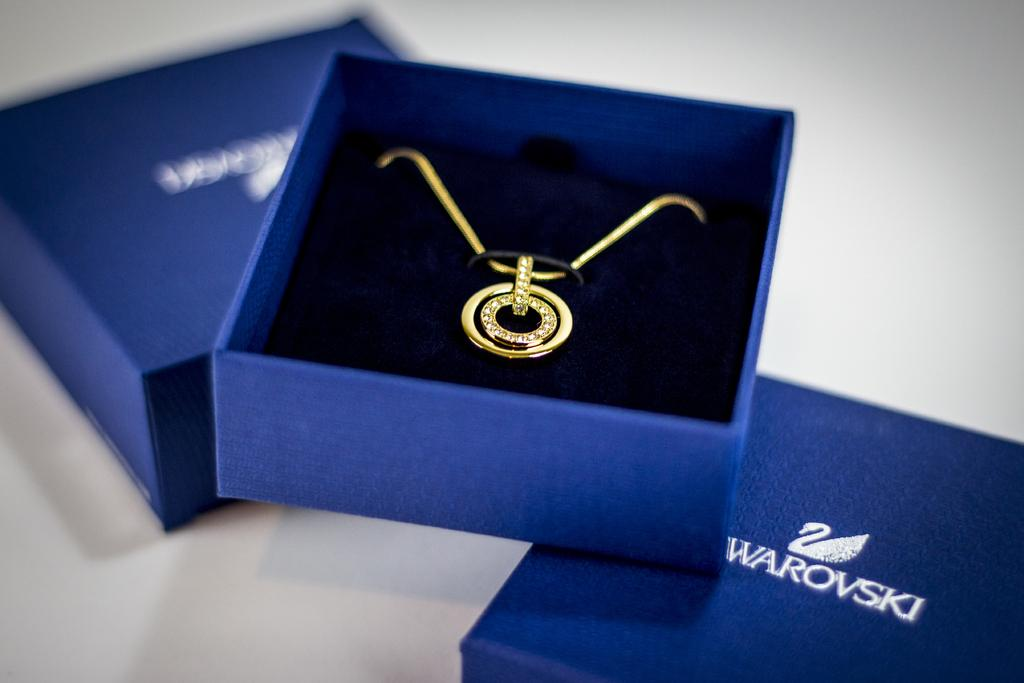What is inside the box that is visible in the image? There is a chain with a pendant in a box in the image. How many boxes are present in the image? There are two boxes in the image. Where is the box with the chain and pendant located? The box with the chain and pendant is placed on a surface. How many pigs are present in the image? There are no pigs present in the image. What event is taking place in the image? There is no event depicted in the image; it simply shows a box with a chain and pendant. 